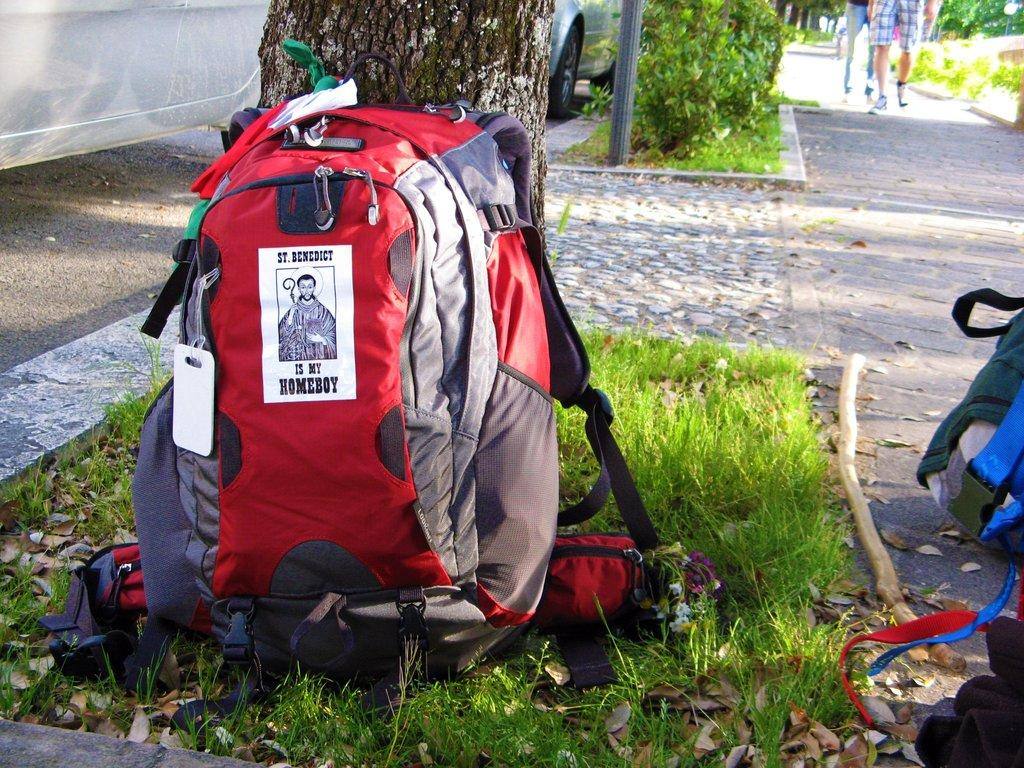What is on the floor in the image? There is a bag and grass on the floor in the image. What can be seen in the background of the image? There is a person walking, a tree, a pole, and a car in the background of the image. What type of leather is used to make the stick in the image? There is no stick or leather present in the image. What is the afterthought in the image? The provided facts do not mention an afterthought, so it cannot be identified in the image. 